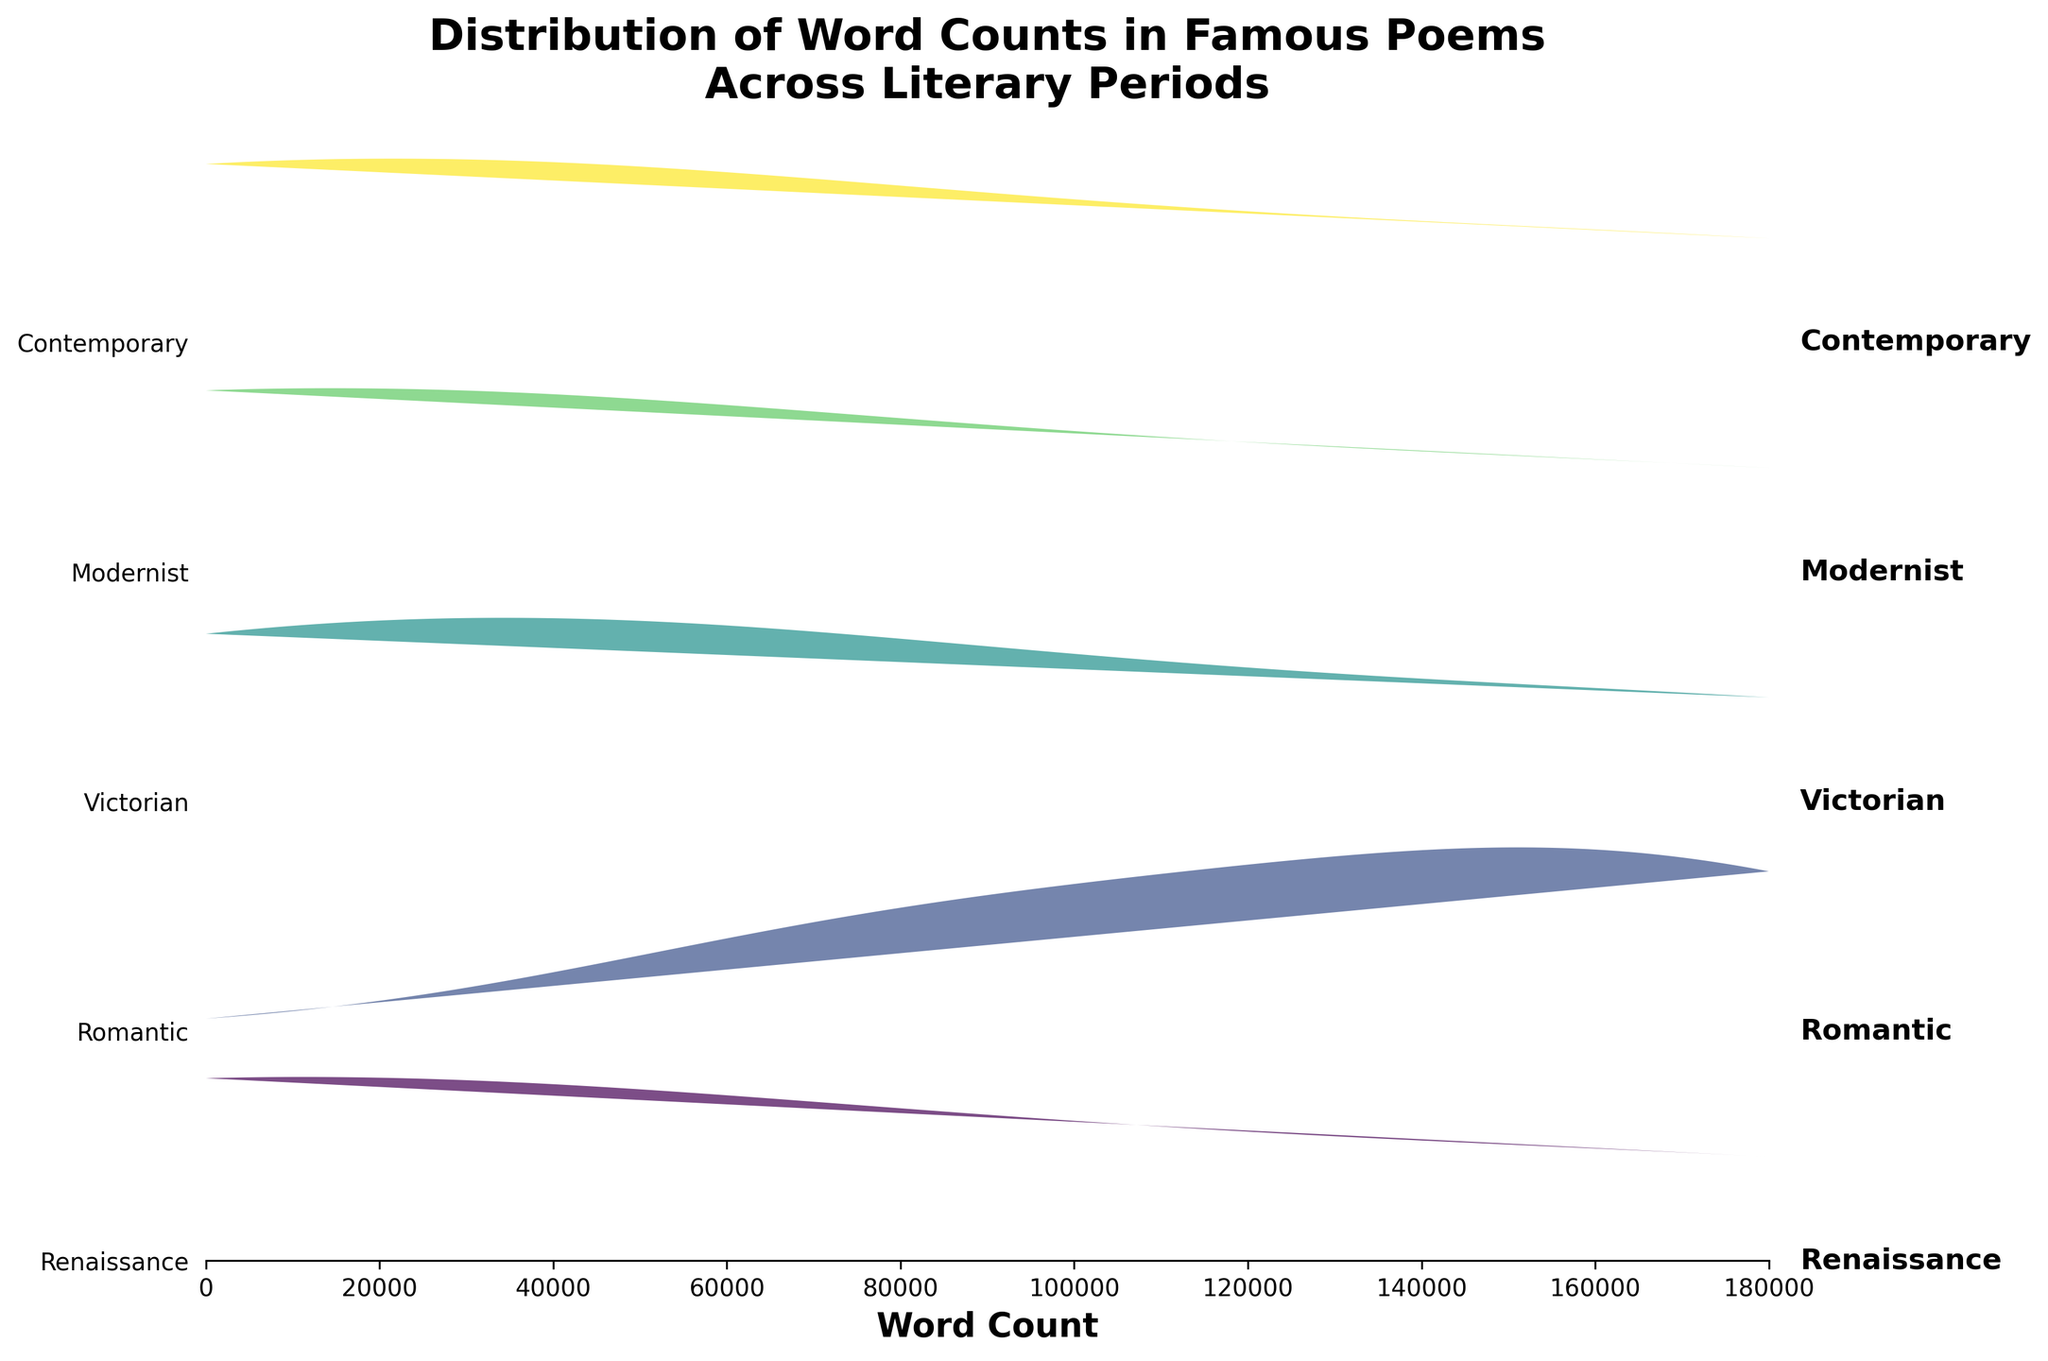What is the title of the figure? The title is usually located at the top of the figure and provides a brief description of what the figure illustrates. In this figure, the title is "Distribution of Word Counts in Famous Poems Across Literary Periods."
Answer: Distribution of Word Counts in Famous Poems Across Literary Periods How many literary periods are represented in the figure? The different literary periods are indicated on the y-axis of the Ridgeline plot. Each period is represented as a separate label on the y-axis. By counting the number of labels, we can determine how many literary periods are shown.
Answer: Four Which literary period shows the highest word count distribution peak, and approximately what word count value does it peak at? The highest word count distribution peak can be identified by looking for the tallest ridge or peak across the four periods. By locating the tallest ridge and observing the word count value where it peaks, we can determine the answer.
Answer: Modernist, approximately 50-100 Which literary period has the lowest word count distribution peak, and what is the approximate word count value? By observing the figure and identifying the shortest peak among the ridges, we can determine which period has the lowest word count distribution peak. The word count value corresponding to this peak gives the final answer.
Answer: Modernist, approximately 3000-3130 How does the word count distribution of Victorian literature compare to that of Romantic literature? We need to compare the ridges of Victorian literature and Romantic literature by observing their respective peak heights and word count ranges. This comparison involves analyzing the relative positions and shapes of the ridges.
Answer: Victorian has a lower peak and broader range than Romantic Which two literary periods show the most similar word count distributions? By observing the ridges for similarities in shape, peak height, and range, we can identify the two literary periods that display the most similar distributions in terms of word counts.
Answer: Renaissance and Contemporary Approximately how many word counts does the Romantic literary period's word count distribution peak at? The peak of the ridge for the Romantic period can be identified by the highest point on the ridge. Observing where this peak occurs on the x-axis gives us the approximate word count value.
Answer: Approximately 150 Among the periods represented, which one shows the greatest range of word counts? The range in this context can be identified by the span of the ridge along the x-axis for each period. The literary period with the ridge spanning the largest part of the x-axis represents the greatest range of word counts.
Answer: Renaissance What can you infer about the word count distribution of Contemporary poems based on the positions of their ridges? By observing the height, shape, and distribution of the Contemporary period's ridge relative to other ridges, we can infer the characteristics of their word count distribution. This involves noting its position and comparing it to other periods.
Answer: Generally lower distribution range than others, peaking around 154-208 